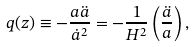Convert formula to latex. <formula><loc_0><loc_0><loc_500><loc_500>q ( z ) \equiv - \frac { a \ddot { a } } { { { \dot { a } } ^ { 2 } } } = - \frac { 1 } { H ^ { 2 } } \left ( \frac { \ddot { a } } { a } \right ) ,</formula> 